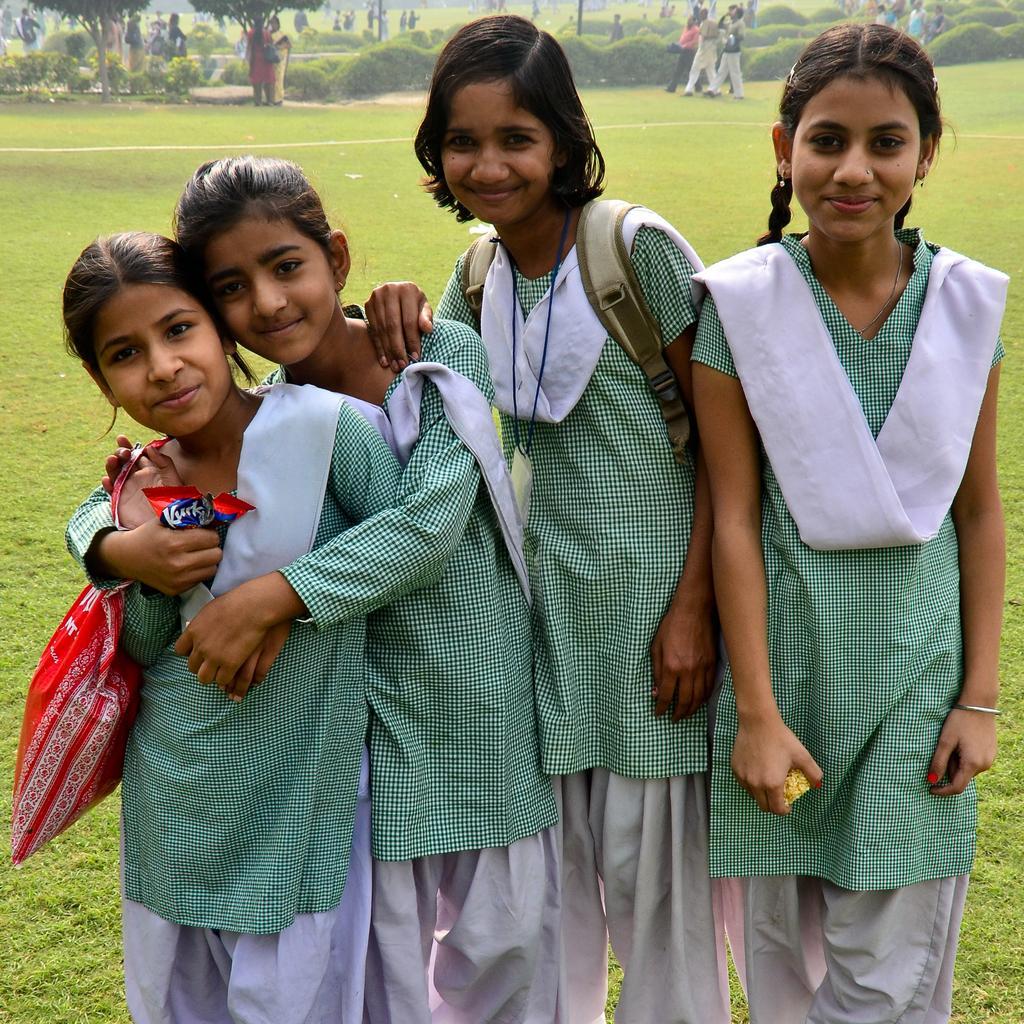Describe this image in one or two sentences. In this picture we can see group of people, few are standing and few are walking on the grass, in the background we can find few trees, on the left side of the image we can see a plastic bag. 